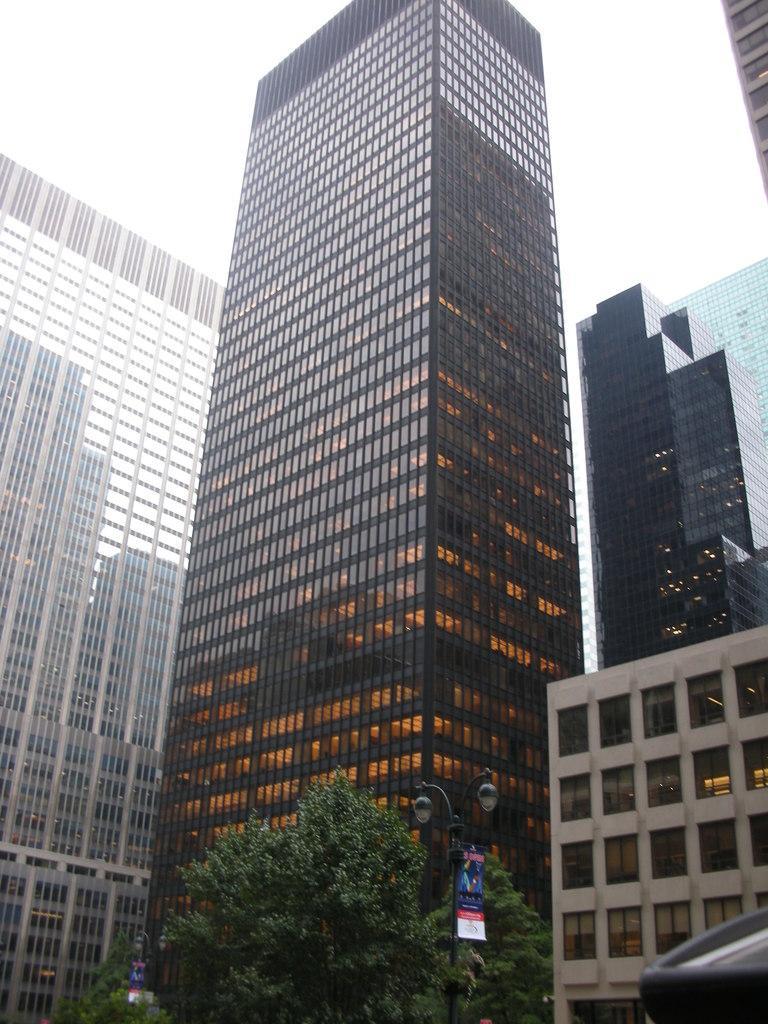In one or two sentences, can you explain what this image depicts? In this image, I can see the buildings with the glass doors. At the bottom of the image, there are trees and light poles. 